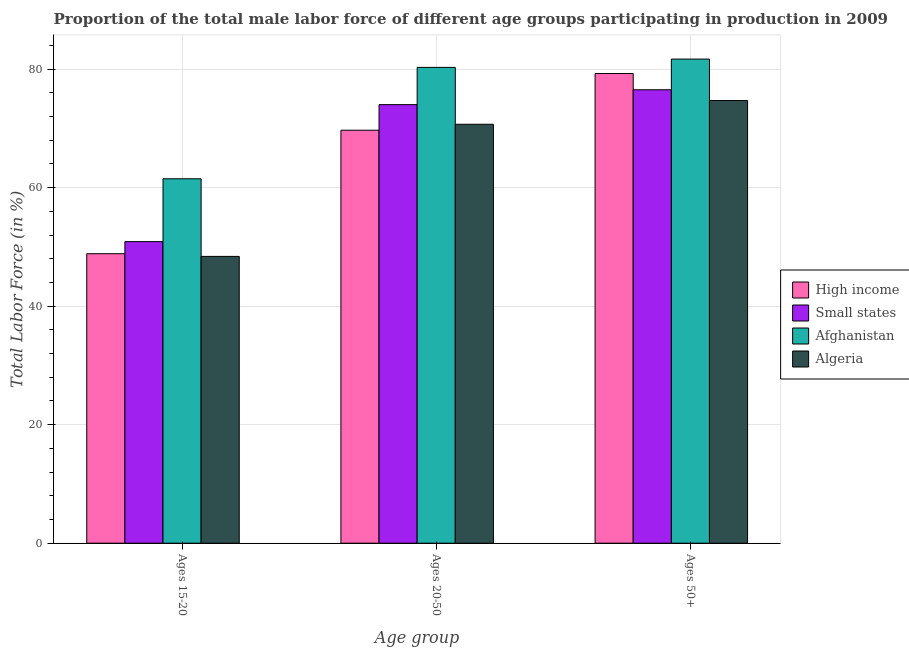How many groups of bars are there?
Your answer should be compact. 3. Are the number of bars per tick equal to the number of legend labels?
Provide a succinct answer. Yes. Are the number of bars on each tick of the X-axis equal?
Keep it short and to the point. Yes. How many bars are there on the 1st tick from the right?
Provide a succinct answer. 4. What is the label of the 1st group of bars from the left?
Provide a short and direct response. Ages 15-20. What is the percentage of male labor force within the age group 15-20 in High income?
Your answer should be compact. 48.85. Across all countries, what is the maximum percentage of male labor force within the age group 20-50?
Give a very brief answer. 80.3. Across all countries, what is the minimum percentage of male labor force above age 50?
Offer a very short reply. 74.7. In which country was the percentage of male labor force within the age group 20-50 maximum?
Offer a very short reply. Afghanistan. In which country was the percentage of male labor force within the age group 20-50 minimum?
Your answer should be compact. High income. What is the total percentage of male labor force above age 50 in the graph?
Ensure brevity in your answer.  312.18. What is the difference between the percentage of male labor force above age 50 in Algeria and that in Small states?
Your answer should be very brief. -1.82. What is the difference between the percentage of male labor force within the age group 15-20 in High income and the percentage of male labor force within the age group 20-50 in Algeria?
Your answer should be very brief. -21.85. What is the average percentage of male labor force within the age group 20-50 per country?
Offer a terse response. 73.68. What is the difference between the percentage of male labor force above age 50 and percentage of male labor force within the age group 20-50 in Small states?
Offer a terse response. 2.51. What is the ratio of the percentage of male labor force above age 50 in High income to that in Small states?
Make the answer very short. 1.04. Is the percentage of male labor force within the age group 15-20 in Small states less than that in High income?
Provide a short and direct response. No. What is the difference between the highest and the second highest percentage of male labor force within the age group 20-50?
Provide a succinct answer. 6.29. What is the difference between the highest and the lowest percentage of male labor force within the age group 20-50?
Give a very brief answer. 10.6. Is the sum of the percentage of male labor force within the age group 15-20 in Algeria and Small states greater than the maximum percentage of male labor force within the age group 20-50 across all countries?
Your answer should be compact. Yes. What does the 3rd bar from the left in Ages 15-20 represents?
Your response must be concise. Afghanistan. What does the 2nd bar from the right in Ages 20-50 represents?
Offer a very short reply. Afghanistan. How many bars are there?
Make the answer very short. 12. How many countries are there in the graph?
Make the answer very short. 4. What is the difference between two consecutive major ticks on the Y-axis?
Provide a succinct answer. 20. Does the graph contain any zero values?
Ensure brevity in your answer.  No. Does the graph contain grids?
Your answer should be very brief. Yes. Where does the legend appear in the graph?
Keep it short and to the point. Center right. How many legend labels are there?
Offer a very short reply. 4. How are the legend labels stacked?
Your answer should be compact. Vertical. What is the title of the graph?
Your answer should be compact. Proportion of the total male labor force of different age groups participating in production in 2009. What is the label or title of the X-axis?
Keep it short and to the point. Age group. What is the Total Labor Force (in %) in High income in Ages 15-20?
Ensure brevity in your answer.  48.85. What is the Total Labor Force (in %) of Small states in Ages 15-20?
Your answer should be very brief. 50.89. What is the Total Labor Force (in %) in Afghanistan in Ages 15-20?
Your answer should be compact. 61.5. What is the Total Labor Force (in %) in Algeria in Ages 15-20?
Offer a terse response. 48.4. What is the Total Labor Force (in %) of High income in Ages 20-50?
Keep it short and to the point. 69.7. What is the Total Labor Force (in %) of Small states in Ages 20-50?
Ensure brevity in your answer.  74.01. What is the Total Labor Force (in %) of Afghanistan in Ages 20-50?
Your answer should be very brief. 80.3. What is the Total Labor Force (in %) in Algeria in Ages 20-50?
Ensure brevity in your answer.  70.7. What is the Total Labor Force (in %) in High income in Ages 50+?
Make the answer very short. 79.26. What is the Total Labor Force (in %) of Small states in Ages 50+?
Make the answer very short. 76.52. What is the Total Labor Force (in %) in Afghanistan in Ages 50+?
Your response must be concise. 81.7. What is the Total Labor Force (in %) of Algeria in Ages 50+?
Your response must be concise. 74.7. Across all Age group, what is the maximum Total Labor Force (in %) of High income?
Provide a short and direct response. 79.26. Across all Age group, what is the maximum Total Labor Force (in %) of Small states?
Your answer should be very brief. 76.52. Across all Age group, what is the maximum Total Labor Force (in %) of Afghanistan?
Your answer should be very brief. 81.7. Across all Age group, what is the maximum Total Labor Force (in %) of Algeria?
Your response must be concise. 74.7. Across all Age group, what is the minimum Total Labor Force (in %) in High income?
Offer a very short reply. 48.85. Across all Age group, what is the minimum Total Labor Force (in %) of Small states?
Keep it short and to the point. 50.89. Across all Age group, what is the minimum Total Labor Force (in %) in Afghanistan?
Provide a short and direct response. 61.5. Across all Age group, what is the minimum Total Labor Force (in %) in Algeria?
Give a very brief answer. 48.4. What is the total Total Labor Force (in %) in High income in the graph?
Make the answer very short. 197.81. What is the total Total Labor Force (in %) in Small states in the graph?
Give a very brief answer. 201.43. What is the total Total Labor Force (in %) of Afghanistan in the graph?
Give a very brief answer. 223.5. What is the total Total Labor Force (in %) in Algeria in the graph?
Make the answer very short. 193.8. What is the difference between the Total Labor Force (in %) in High income in Ages 15-20 and that in Ages 20-50?
Give a very brief answer. -20.84. What is the difference between the Total Labor Force (in %) in Small states in Ages 15-20 and that in Ages 20-50?
Give a very brief answer. -23.12. What is the difference between the Total Labor Force (in %) of Afghanistan in Ages 15-20 and that in Ages 20-50?
Your answer should be compact. -18.8. What is the difference between the Total Labor Force (in %) of Algeria in Ages 15-20 and that in Ages 20-50?
Your answer should be compact. -22.3. What is the difference between the Total Labor Force (in %) of High income in Ages 15-20 and that in Ages 50+?
Make the answer very short. -30.41. What is the difference between the Total Labor Force (in %) in Small states in Ages 15-20 and that in Ages 50+?
Provide a short and direct response. -25.63. What is the difference between the Total Labor Force (in %) of Afghanistan in Ages 15-20 and that in Ages 50+?
Offer a very short reply. -20.2. What is the difference between the Total Labor Force (in %) in Algeria in Ages 15-20 and that in Ages 50+?
Offer a very short reply. -26.3. What is the difference between the Total Labor Force (in %) of High income in Ages 20-50 and that in Ages 50+?
Keep it short and to the point. -9.57. What is the difference between the Total Labor Force (in %) of Small states in Ages 20-50 and that in Ages 50+?
Offer a terse response. -2.51. What is the difference between the Total Labor Force (in %) in Algeria in Ages 20-50 and that in Ages 50+?
Ensure brevity in your answer.  -4. What is the difference between the Total Labor Force (in %) in High income in Ages 15-20 and the Total Labor Force (in %) in Small states in Ages 20-50?
Your answer should be very brief. -25.16. What is the difference between the Total Labor Force (in %) of High income in Ages 15-20 and the Total Labor Force (in %) of Afghanistan in Ages 20-50?
Your answer should be compact. -31.45. What is the difference between the Total Labor Force (in %) in High income in Ages 15-20 and the Total Labor Force (in %) in Algeria in Ages 20-50?
Keep it short and to the point. -21.85. What is the difference between the Total Labor Force (in %) in Small states in Ages 15-20 and the Total Labor Force (in %) in Afghanistan in Ages 20-50?
Offer a terse response. -29.41. What is the difference between the Total Labor Force (in %) in Small states in Ages 15-20 and the Total Labor Force (in %) in Algeria in Ages 20-50?
Offer a very short reply. -19.81. What is the difference between the Total Labor Force (in %) of High income in Ages 15-20 and the Total Labor Force (in %) of Small states in Ages 50+?
Make the answer very short. -27.67. What is the difference between the Total Labor Force (in %) of High income in Ages 15-20 and the Total Labor Force (in %) of Afghanistan in Ages 50+?
Ensure brevity in your answer.  -32.85. What is the difference between the Total Labor Force (in %) in High income in Ages 15-20 and the Total Labor Force (in %) in Algeria in Ages 50+?
Your answer should be very brief. -25.85. What is the difference between the Total Labor Force (in %) in Small states in Ages 15-20 and the Total Labor Force (in %) in Afghanistan in Ages 50+?
Offer a very short reply. -30.81. What is the difference between the Total Labor Force (in %) in Small states in Ages 15-20 and the Total Labor Force (in %) in Algeria in Ages 50+?
Your answer should be very brief. -23.81. What is the difference between the Total Labor Force (in %) in High income in Ages 20-50 and the Total Labor Force (in %) in Small states in Ages 50+?
Provide a succinct answer. -6.83. What is the difference between the Total Labor Force (in %) of High income in Ages 20-50 and the Total Labor Force (in %) of Afghanistan in Ages 50+?
Make the answer very short. -12. What is the difference between the Total Labor Force (in %) in High income in Ages 20-50 and the Total Labor Force (in %) in Algeria in Ages 50+?
Your answer should be very brief. -5. What is the difference between the Total Labor Force (in %) in Small states in Ages 20-50 and the Total Labor Force (in %) in Afghanistan in Ages 50+?
Provide a short and direct response. -7.69. What is the difference between the Total Labor Force (in %) in Small states in Ages 20-50 and the Total Labor Force (in %) in Algeria in Ages 50+?
Your response must be concise. -0.69. What is the difference between the Total Labor Force (in %) of Afghanistan in Ages 20-50 and the Total Labor Force (in %) of Algeria in Ages 50+?
Your response must be concise. 5.6. What is the average Total Labor Force (in %) of High income per Age group?
Offer a very short reply. 65.94. What is the average Total Labor Force (in %) in Small states per Age group?
Provide a short and direct response. 67.14. What is the average Total Labor Force (in %) in Afghanistan per Age group?
Provide a short and direct response. 74.5. What is the average Total Labor Force (in %) of Algeria per Age group?
Provide a succinct answer. 64.6. What is the difference between the Total Labor Force (in %) in High income and Total Labor Force (in %) in Small states in Ages 15-20?
Give a very brief answer. -2.04. What is the difference between the Total Labor Force (in %) of High income and Total Labor Force (in %) of Afghanistan in Ages 15-20?
Provide a short and direct response. -12.65. What is the difference between the Total Labor Force (in %) of High income and Total Labor Force (in %) of Algeria in Ages 15-20?
Make the answer very short. 0.45. What is the difference between the Total Labor Force (in %) in Small states and Total Labor Force (in %) in Afghanistan in Ages 15-20?
Your answer should be compact. -10.61. What is the difference between the Total Labor Force (in %) in Small states and Total Labor Force (in %) in Algeria in Ages 15-20?
Provide a short and direct response. 2.49. What is the difference between the Total Labor Force (in %) in High income and Total Labor Force (in %) in Small states in Ages 20-50?
Your response must be concise. -4.32. What is the difference between the Total Labor Force (in %) of High income and Total Labor Force (in %) of Afghanistan in Ages 20-50?
Keep it short and to the point. -10.6. What is the difference between the Total Labor Force (in %) of High income and Total Labor Force (in %) of Algeria in Ages 20-50?
Offer a terse response. -1. What is the difference between the Total Labor Force (in %) in Small states and Total Labor Force (in %) in Afghanistan in Ages 20-50?
Your response must be concise. -6.29. What is the difference between the Total Labor Force (in %) in Small states and Total Labor Force (in %) in Algeria in Ages 20-50?
Ensure brevity in your answer.  3.31. What is the difference between the Total Labor Force (in %) of Afghanistan and Total Labor Force (in %) of Algeria in Ages 20-50?
Give a very brief answer. 9.6. What is the difference between the Total Labor Force (in %) in High income and Total Labor Force (in %) in Small states in Ages 50+?
Offer a terse response. 2.74. What is the difference between the Total Labor Force (in %) in High income and Total Labor Force (in %) in Afghanistan in Ages 50+?
Give a very brief answer. -2.44. What is the difference between the Total Labor Force (in %) of High income and Total Labor Force (in %) of Algeria in Ages 50+?
Provide a succinct answer. 4.56. What is the difference between the Total Labor Force (in %) in Small states and Total Labor Force (in %) in Afghanistan in Ages 50+?
Provide a short and direct response. -5.18. What is the difference between the Total Labor Force (in %) in Small states and Total Labor Force (in %) in Algeria in Ages 50+?
Your answer should be compact. 1.82. What is the ratio of the Total Labor Force (in %) of High income in Ages 15-20 to that in Ages 20-50?
Your answer should be very brief. 0.7. What is the ratio of the Total Labor Force (in %) of Small states in Ages 15-20 to that in Ages 20-50?
Ensure brevity in your answer.  0.69. What is the ratio of the Total Labor Force (in %) of Afghanistan in Ages 15-20 to that in Ages 20-50?
Provide a short and direct response. 0.77. What is the ratio of the Total Labor Force (in %) in Algeria in Ages 15-20 to that in Ages 20-50?
Give a very brief answer. 0.68. What is the ratio of the Total Labor Force (in %) of High income in Ages 15-20 to that in Ages 50+?
Provide a succinct answer. 0.62. What is the ratio of the Total Labor Force (in %) in Small states in Ages 15-20 to that in Ages 50+?
Your response must be concise. 0.67. What is the ratio of the Total Labor Force (in %) in Afghanistan in Ages 15-20 to that in Ages 50+?
Ensure brevity in your answer.  0.75. What is the ratio of the Total Labor Force (in %) in Algeria in Ages 15-20 to that in Ages 50+?
Give a very brief answer. 0.65. What is the ratio of the Total Labor Force (in %) of High income in Ages 20-50 to that in Ages 50+?
Your answer should be very brief. 0.88. What is the ratio of the Total Labor Force (in %) of Small states in Ages 20-50 to that in Ages 50+?
Make the answer very short. 0.97. What is the ratio of the Total Labor Force (in %) in Afghanistan in Ages 20-50 to that in Ages 50+?
Make the answer very short. 0.98. What is the ratio of the Total Labor Force (in %) in Algeria in Ages 20-50 to that in Ages 50+?
Make the answer very short. 0.95. What is the difference between the highest and the second highest Total Labor Force (in %) in High income?
Provide a short and direct response. 9.57. What is the difference between the highest and the second highest Total Labor Force (in %) in Small states?
Provide a succinct answer. 2.51. What is the difference between the highest and the lowest Total Labor Force (in %) in High income?
Your response must be concise. 30.41. What is the difference between the highest and the lowest Total Labor Force (in %) of Small states?
Give a very brief answer. 25.63. What is the difference between the highest and the lowest Total Labor Force (in %) of Afghanistan?
Ensure brevity in your answer.  20.2. What is the difference between the highest and the lowest Total Labor Force (in %) of Algeria?
Provide a short and direct response. 26.3. 